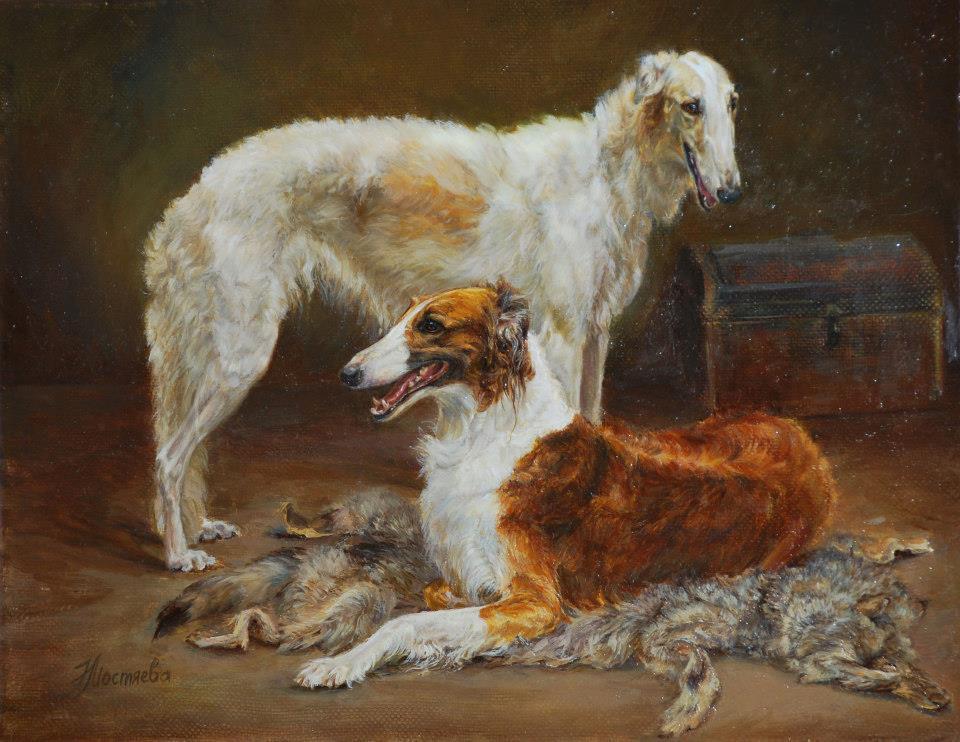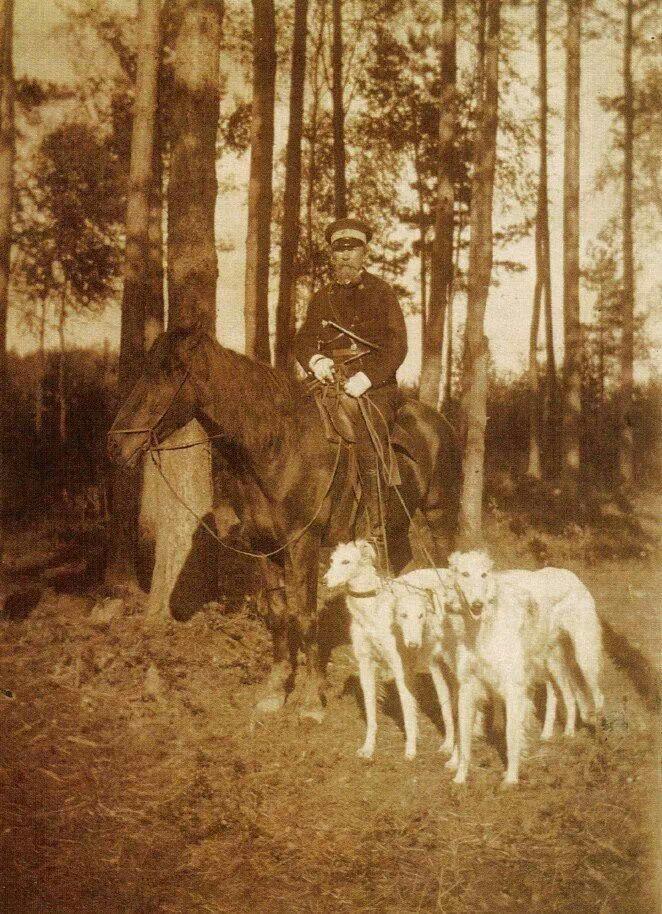The first image is the image on the left, the second image is the image on the right. For the images displayed, is the sentence "An image includes a hound reclining on an animal skin." factually correct? Answer yes or no. Yes. The first image is the image on the left, the second image is the image on the right. Examine the images to the left and right. Is the description "The dogs in the image on the right are outside." accurate? Answer yes or no. Yes. 